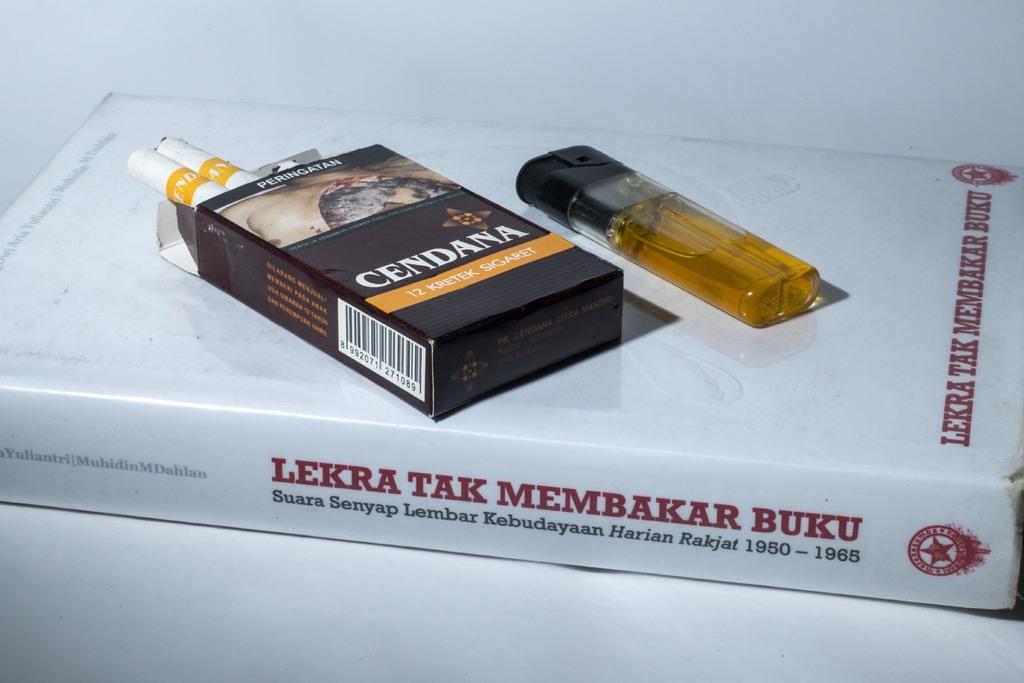What date range is covered in this book?
Provide a short and direct response. 1950-1965. 